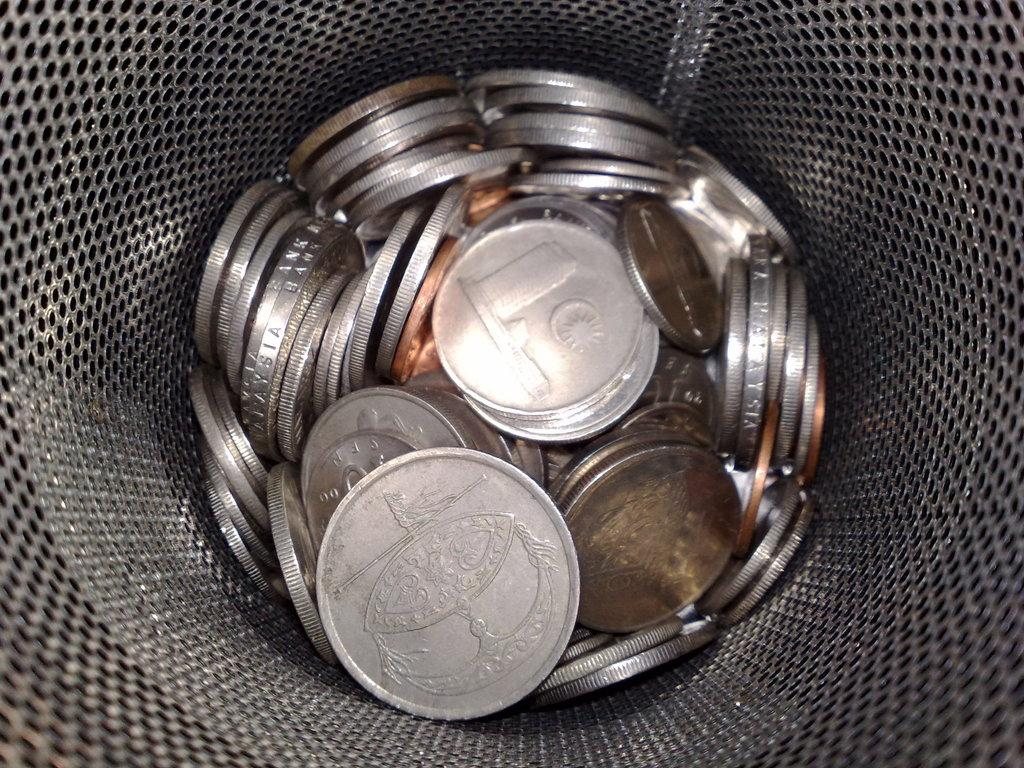What is inside the container in the image? There are coins in a container in the image. Can you describe the container? The container has a mesh. What can be observed about the background of the image? The background of the image is dark. How many tomatoes are in the account in the image? There are no tomatoes or accounts present in the image; it features a container with coins and a mesh. 